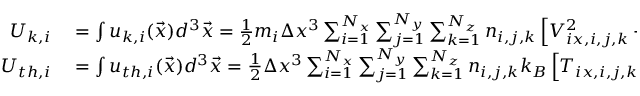Convert formula to latex. <formula><loc_0><loc_0><loc_500><loc_500>\begin{array} { r l } { U _ { k , i } } & = \int u _ { k , i } ( \vec { x } ) d ^ { 3 } \vec { x } = \frac { 1 } { 2 } m _ { i } \Delta x ^ { 3 } \sum _ { i = 1 } ^ { N _ { x } } \sum _ { j = 1 } ^ { N _ { y } } \sum _ { k = 1 } ^ { N _ { z } } n _ { i , j , k } \left [ V _ { i x , i , j , k } ^ { 2 } + V _ { i y , i , j , k } ^ { 2 } + V _ { i z , i , j , k } ^ { 2 } \right ] } \\ { U _ { t h , i } } & = \int u _ { t h , i } ( \vec { x } ) d ^ { 3 } \vec { x } = \frac { 1 } { 2 } \Delta x ^ { 3 } \sum _ { i = 1 } ^ { N _ { x } } \sum _ { j = 1 } ^ { N _ { y } } \sum _ { k = 1 } ^ { N _ { z } } n _ { i , j , k } k _ { B } \left [ T _ { i x , i , j , k } + T _ { i y , i , j , k } + T _ { i z , i , j , k } \right ] } \end{array}</formula> 